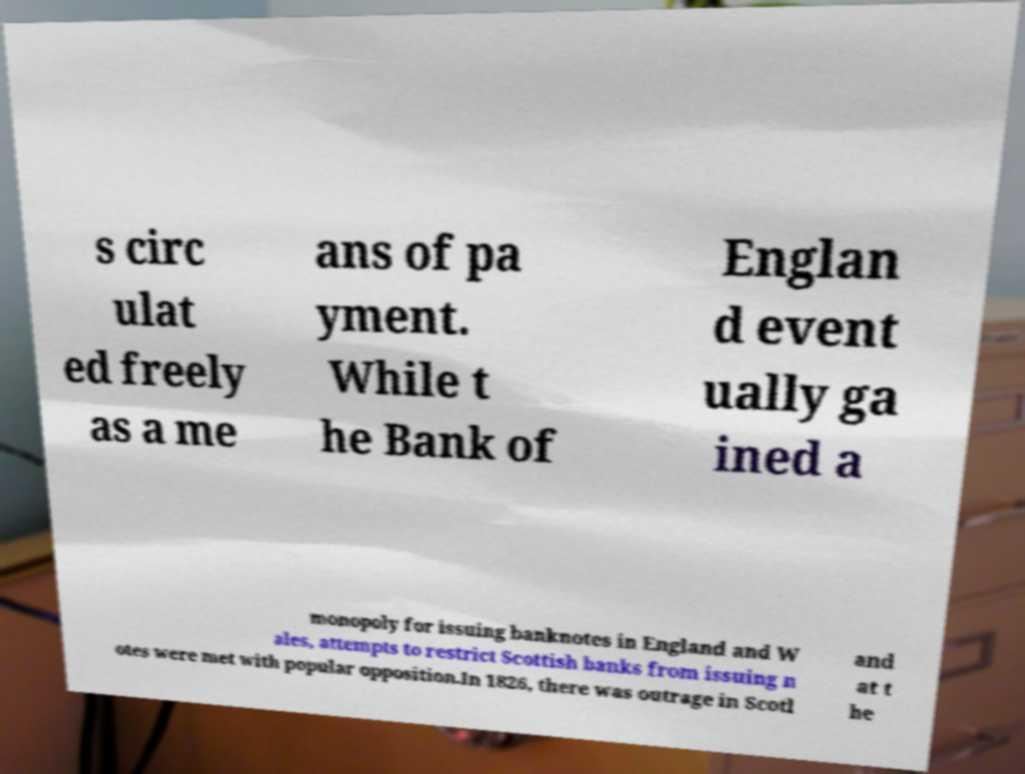There's text embedded in this image that I need extracted. Can you transcribe it verbatim? s circ ulat ed freely as a me ans of pa yment. While t he Bank of Englan d event ually ga ined a monopoly for issuing banknotes in England and W ales, attempts to restrict Scottish banks from issuing n otes were met with popular opposition.In 1826, there was outrage in Scotl and at t he 